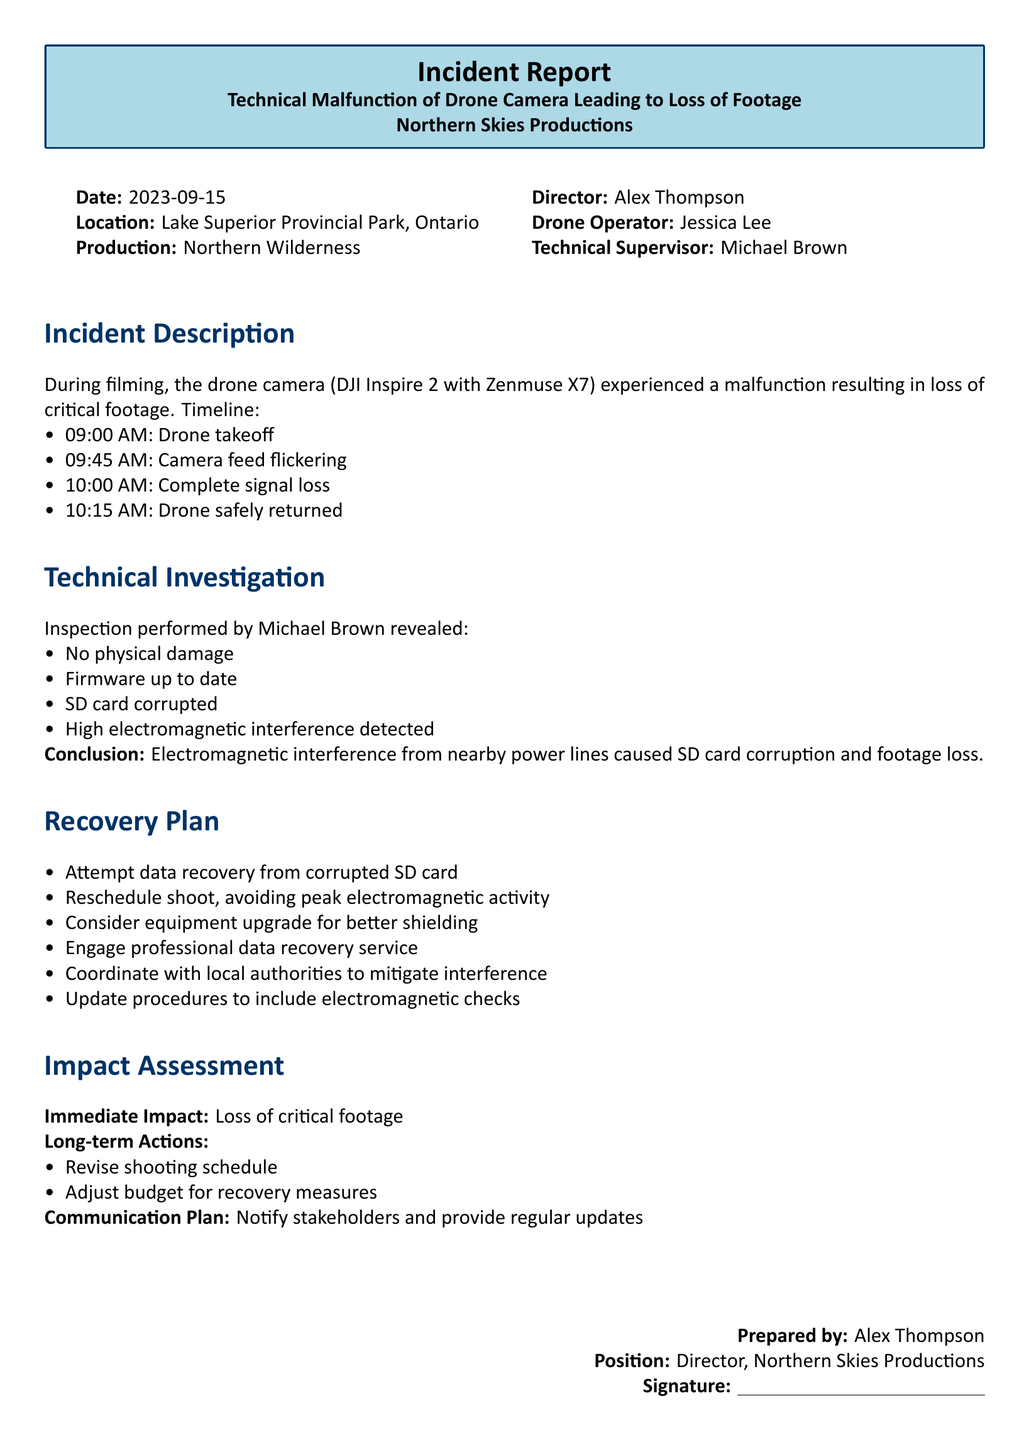What was the date of the incident? The date of the incident is explicitly stated in the document as "2023-09-15."
Answer: 2023-09-15 Who was the drone operator? The drone operator's name is provided in the document, which is "Jessica Lee."
Answer: Jessica Lee What malfunction occurred during filming? The specific malfunction mentioned in the document is the "camera feed flickering" followed by "complete signal loss."
Answer: Camera feed flickering and complete signal loss What caused the loss of footage? The investigation found that the cause of the loss of footage was "electromagnetic interference from nearby power lines."
Answer: Electromagnetic interference from nearby power lines What measures are included in the recovery plan? The recovery plan involves multiple actions, one of which is to "attempt data recovery from corrupted SD card."
Answer: Attempt data recovery from corrupted SD card What was the immediate impact of the incident? The document states the immediate impact was the "loss of critical footage."
Answer: Loss of critical footage Which production was affected by this incident? The affected production is mentioned as "Northern Wilderness."
Answer: Northern Wilderness What is one long-term action mentioned in the report? The report lists "revise shooting schedule" as one of the long-term actions.
Answer: Revise shooting schedule 